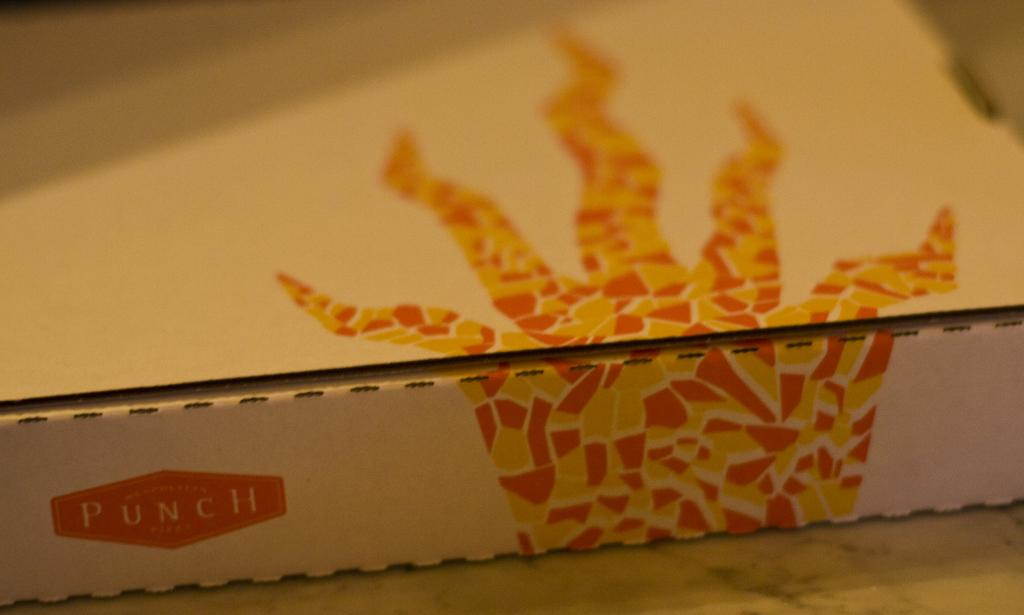<image>
Present a compact description of the photo's key features. The brown takeout pizza box is from Punch pizzeria. 